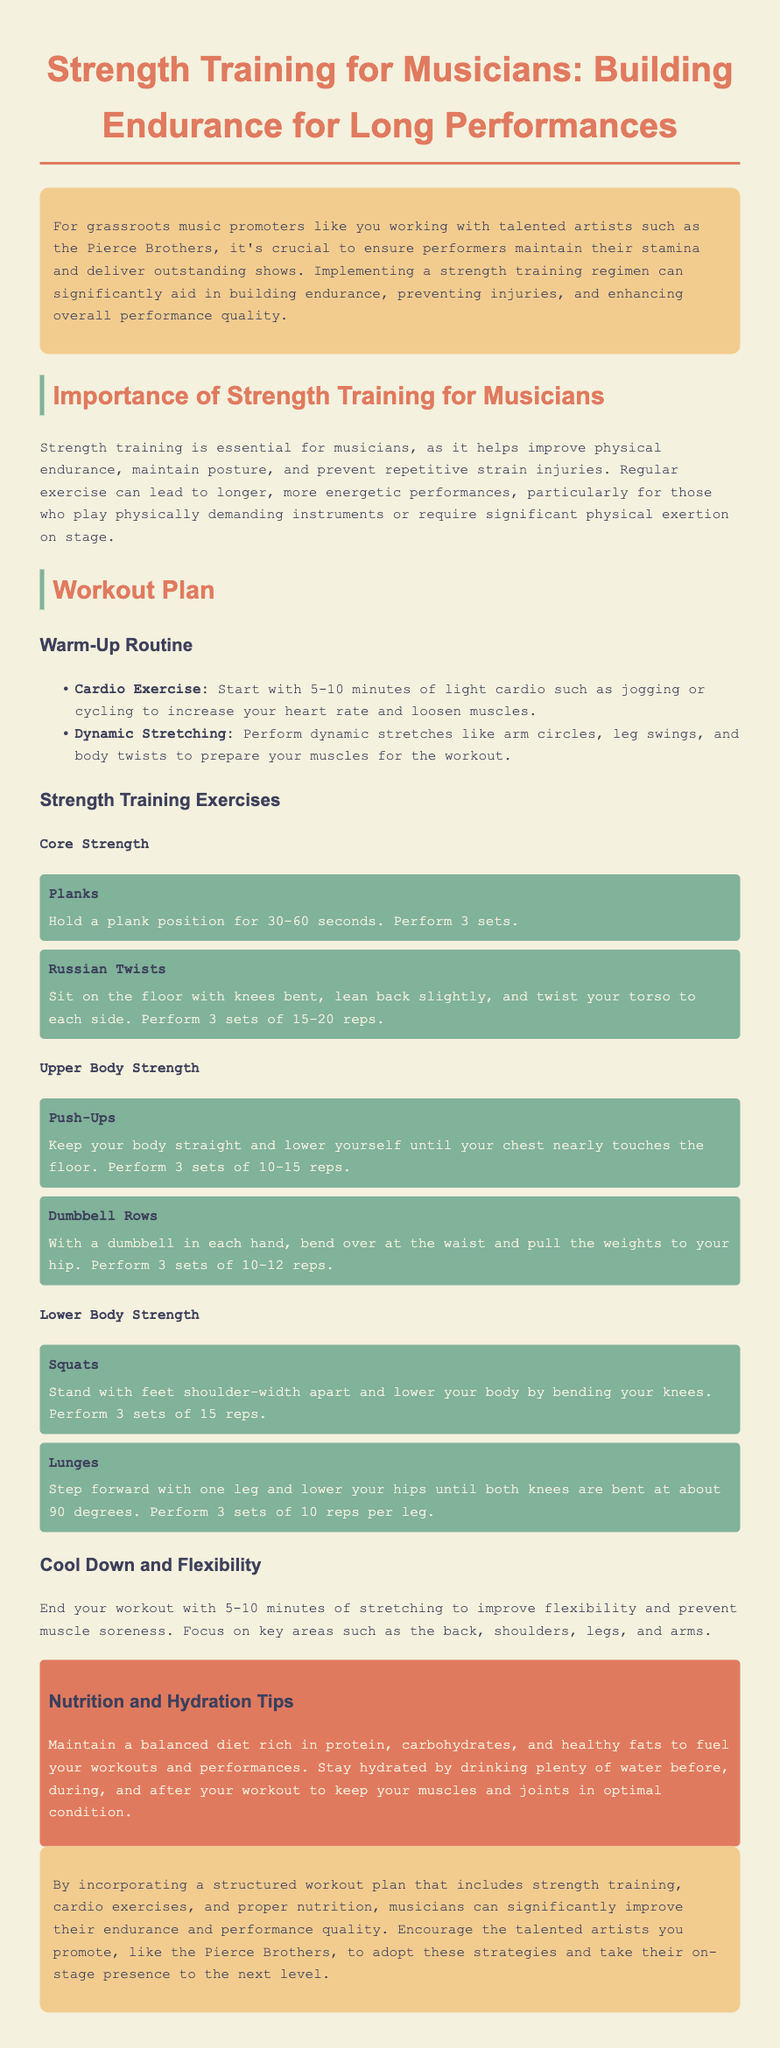What is the title of the document? The title is announced at the start of the document, emphasizing the focus on strength training for musicians.
Answer: Strength Training for Musicians: Building Endurance for Long Performances How long should the warm-up cardio exercise last? The document specifies that the warm-up cardio exercise should last between 5 to 10 minutes.
Answer: 5-10 minutes What is the recommended hold time for planks? The document indicates that planks should be held for 30-60 seconds during the workout.
Answer: 30-60 seconds How many sets of Russian twists should be performed? The document states that 3 sets of Russian twists are to be performed as part of the strength training exercises.
Answer: 3 sets What type of exercise is suggested after the strength training? The document recommends concluding the workout with stretching to improve flexibility and prevent soreness.
Answer: Stretching Why is strength training important for musicians? The document discusses the importance of strength training in improving physical endurance and preventing injuries for musicians.
Answer: Improve physical endurance, prevent injuries What is one key focus area during the cool down? The document mentions focusing on flexibility and muscle soreness during the cool-down phase.
Answer: Flexibility What should musicians maintain a balanced diet rich in? The document advises maintaining a balanced diet rich in protein, carbohydrates, and healthy fats.
Answer: Protein, carbohydrates, healthy fats How many reps are suggested for squats? The document specifies performing 3 sets of 15 reps for squats as part of the workout plan.
Answer: 15 reps 